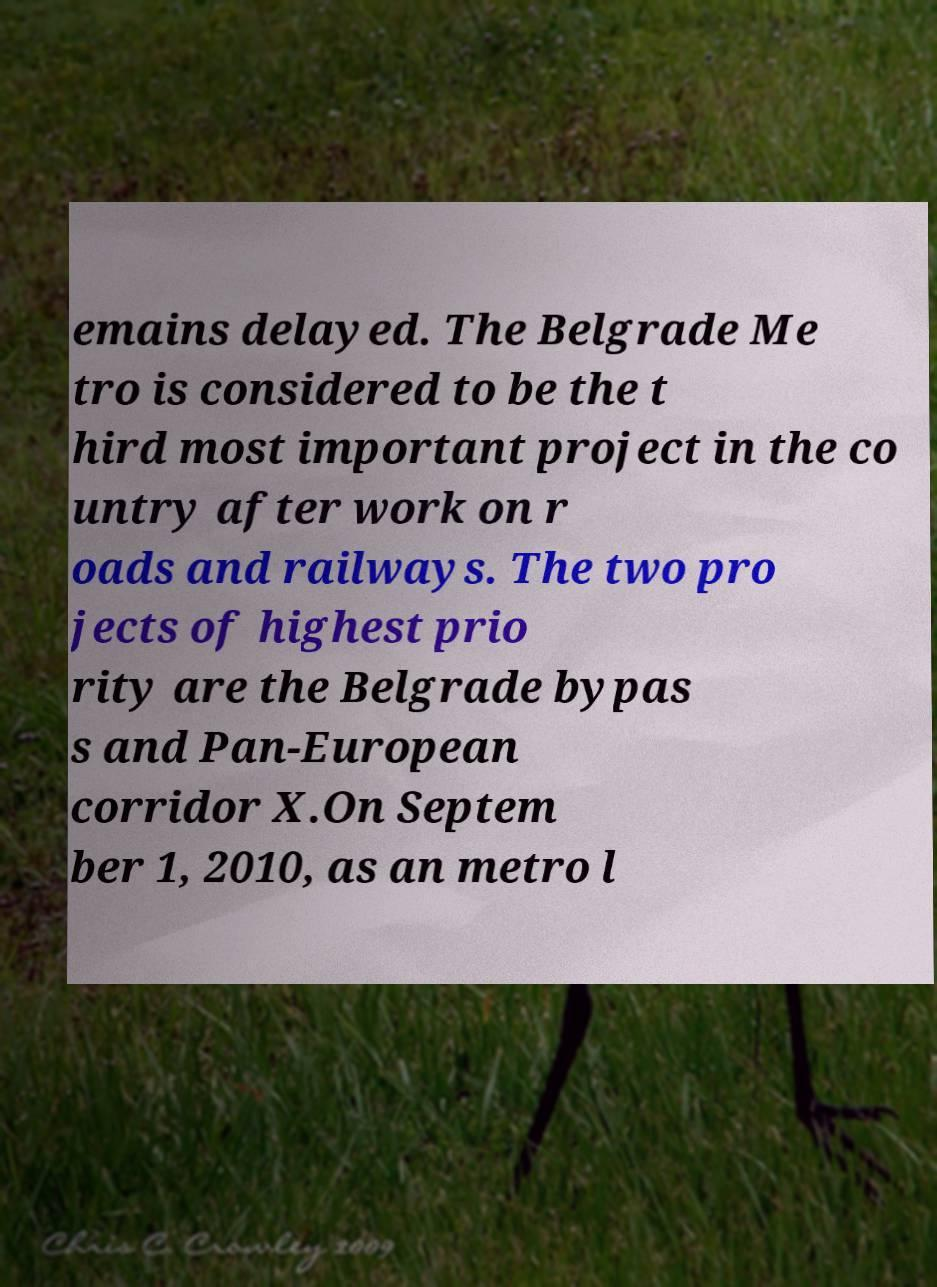Please identify and transcribe the text found in this image. emains delayed. The Belgrade Me tro is considered to be the t hird most important project in the co untry after work on r oads and railways. The two pro jects of highest prio rity are the Belgrade bypas s and Pan-European corridor X.On Septem ber 1, 2010, as an metro l 